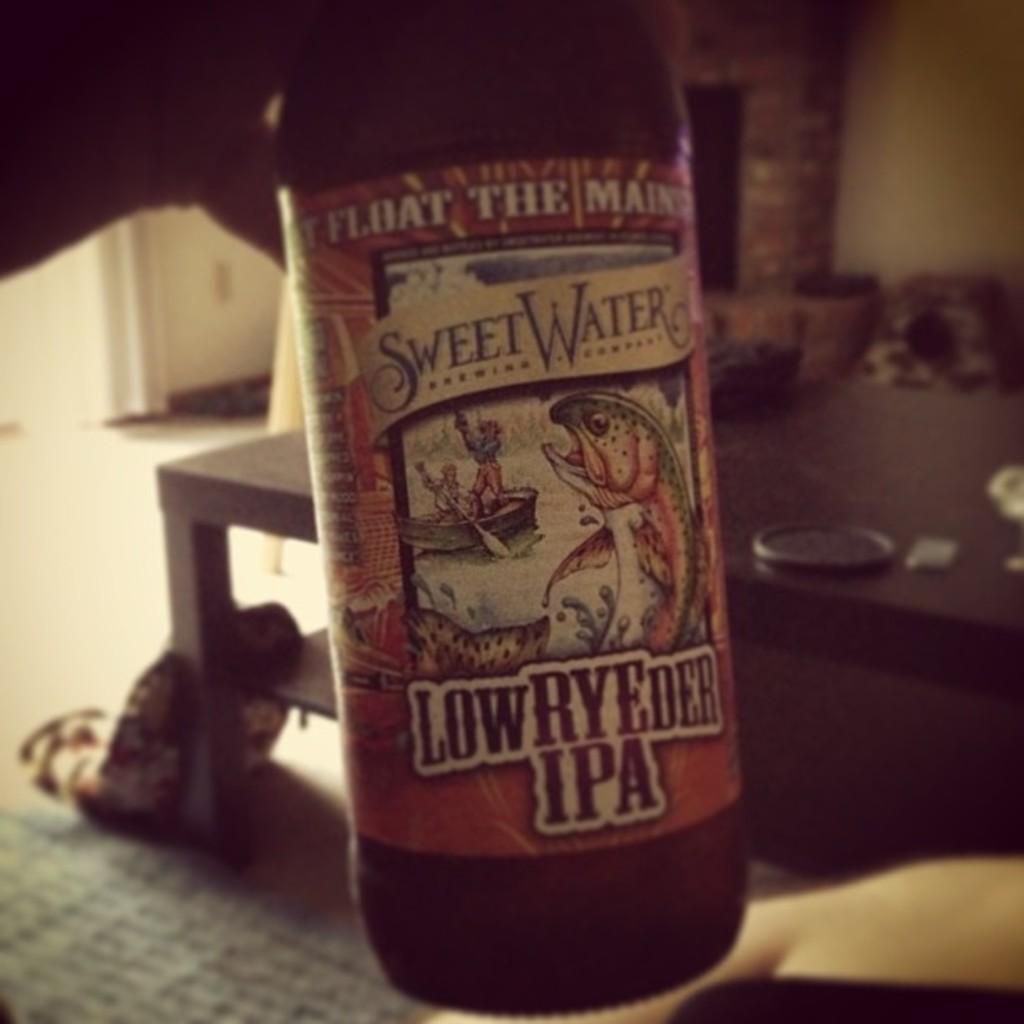<image>
Give a short and clear explanation of the subsequent image. A Sweet Water Low RyeDer IPA bottle of beer with a fish, lake, and fishermen on the label. 